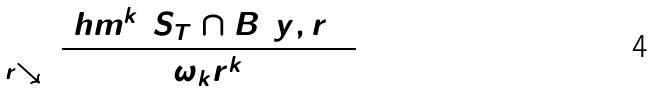Convert formula to latex. <formula><loc_0><loc_0><loc_500><loc_500>\lim _ { r \searrow 0 } \frac { \ h m ^ { k } ( S _ { T } \cap B ( y , r ) ) } { \omega _ { k } r ^ { k } } = 1</formula> 